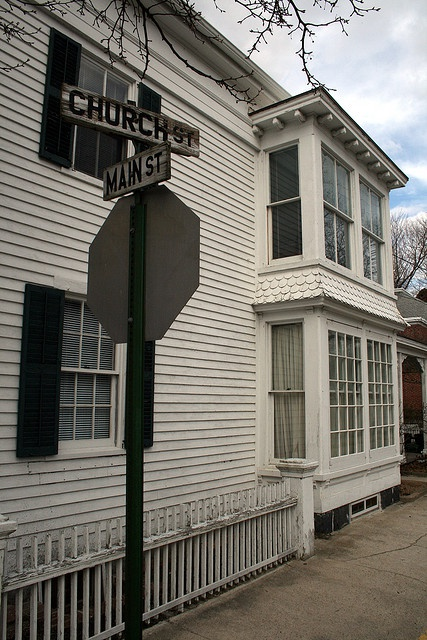Describe the objects in this image and their specific colors. I can see a stop sign in gray and black tones in this image. 